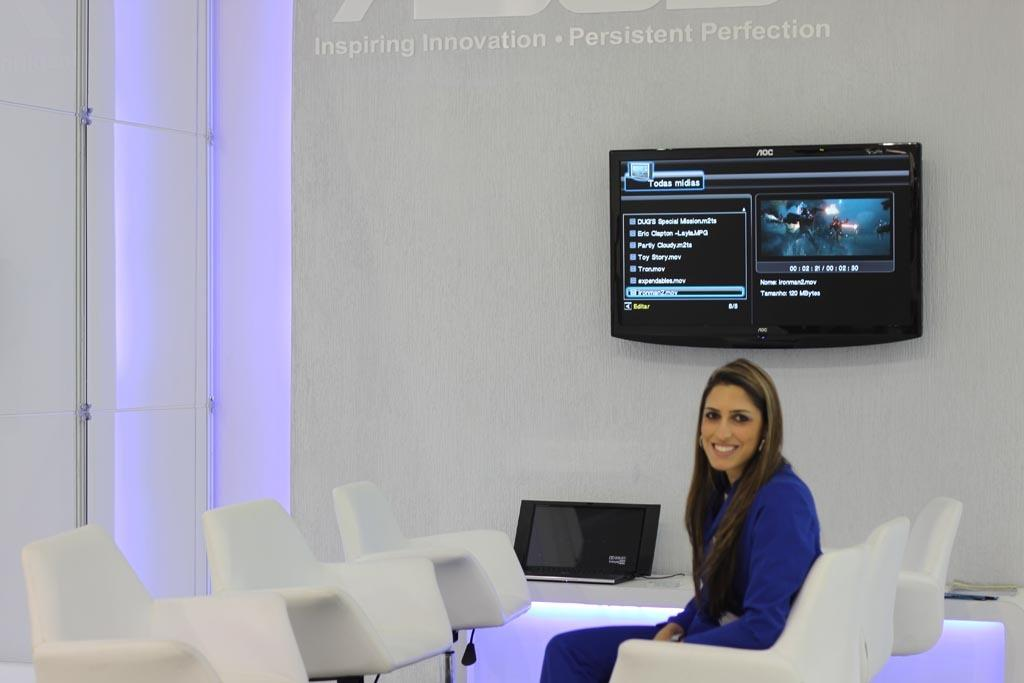Who or what is in the image? There is a person in the image. What is the person doing in the image? The person is sitting on a chair. What can be seen on the wall in the image? There is a TV on the wall in the image. What type of zebra can be seen playing with a string in the image? There is no zebra or string present in the image; it features a person sitting on a chair with a TV on the wall. 